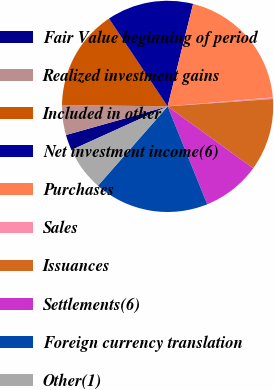<chart> <loc_0><loc_0><loc_500><loc_500><pie_chart><fcel>Fair Value beginning of period<fcel>Realized investment gains<fcel>Included in other<fcel>Net investment income(6)<fcel>Purchases<fcel>Sales<fcel>Issuances<fcel>Settlements(6)<fcel>Foreign currency translation<fcel>Other(1)<nl><fcel>2.41%<fcel>4.58%<fcel>15.42%<fcel>13.25%<fcel>19.76%<fcel>0.24%<fcel>11.08%<fcel>8.92%<fcel>17.59%<fcel>6.75%<nl></chart> 